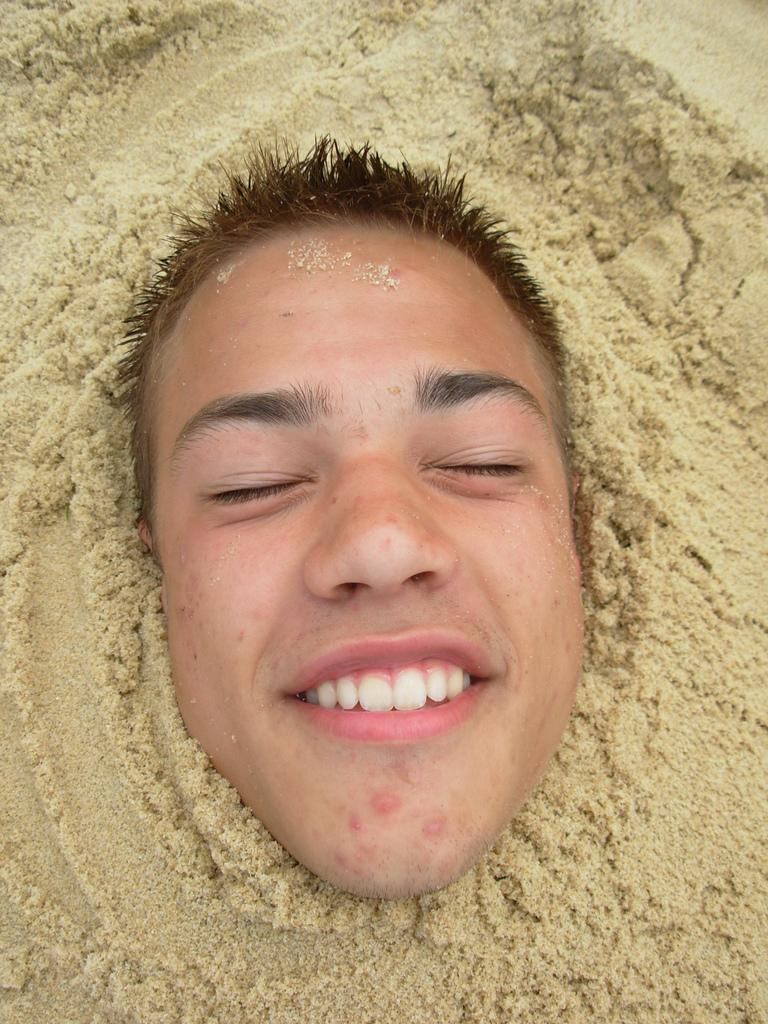What is the main subject of the image? There is a person in the image. What is the person's body covered with? The person's body is covered with sand. Can you see the person's face in the image? Yes, the person's face is visible. What type of cheese is the person holding in the image? There is no cheese present in the image; the person's body is covered with sand. 